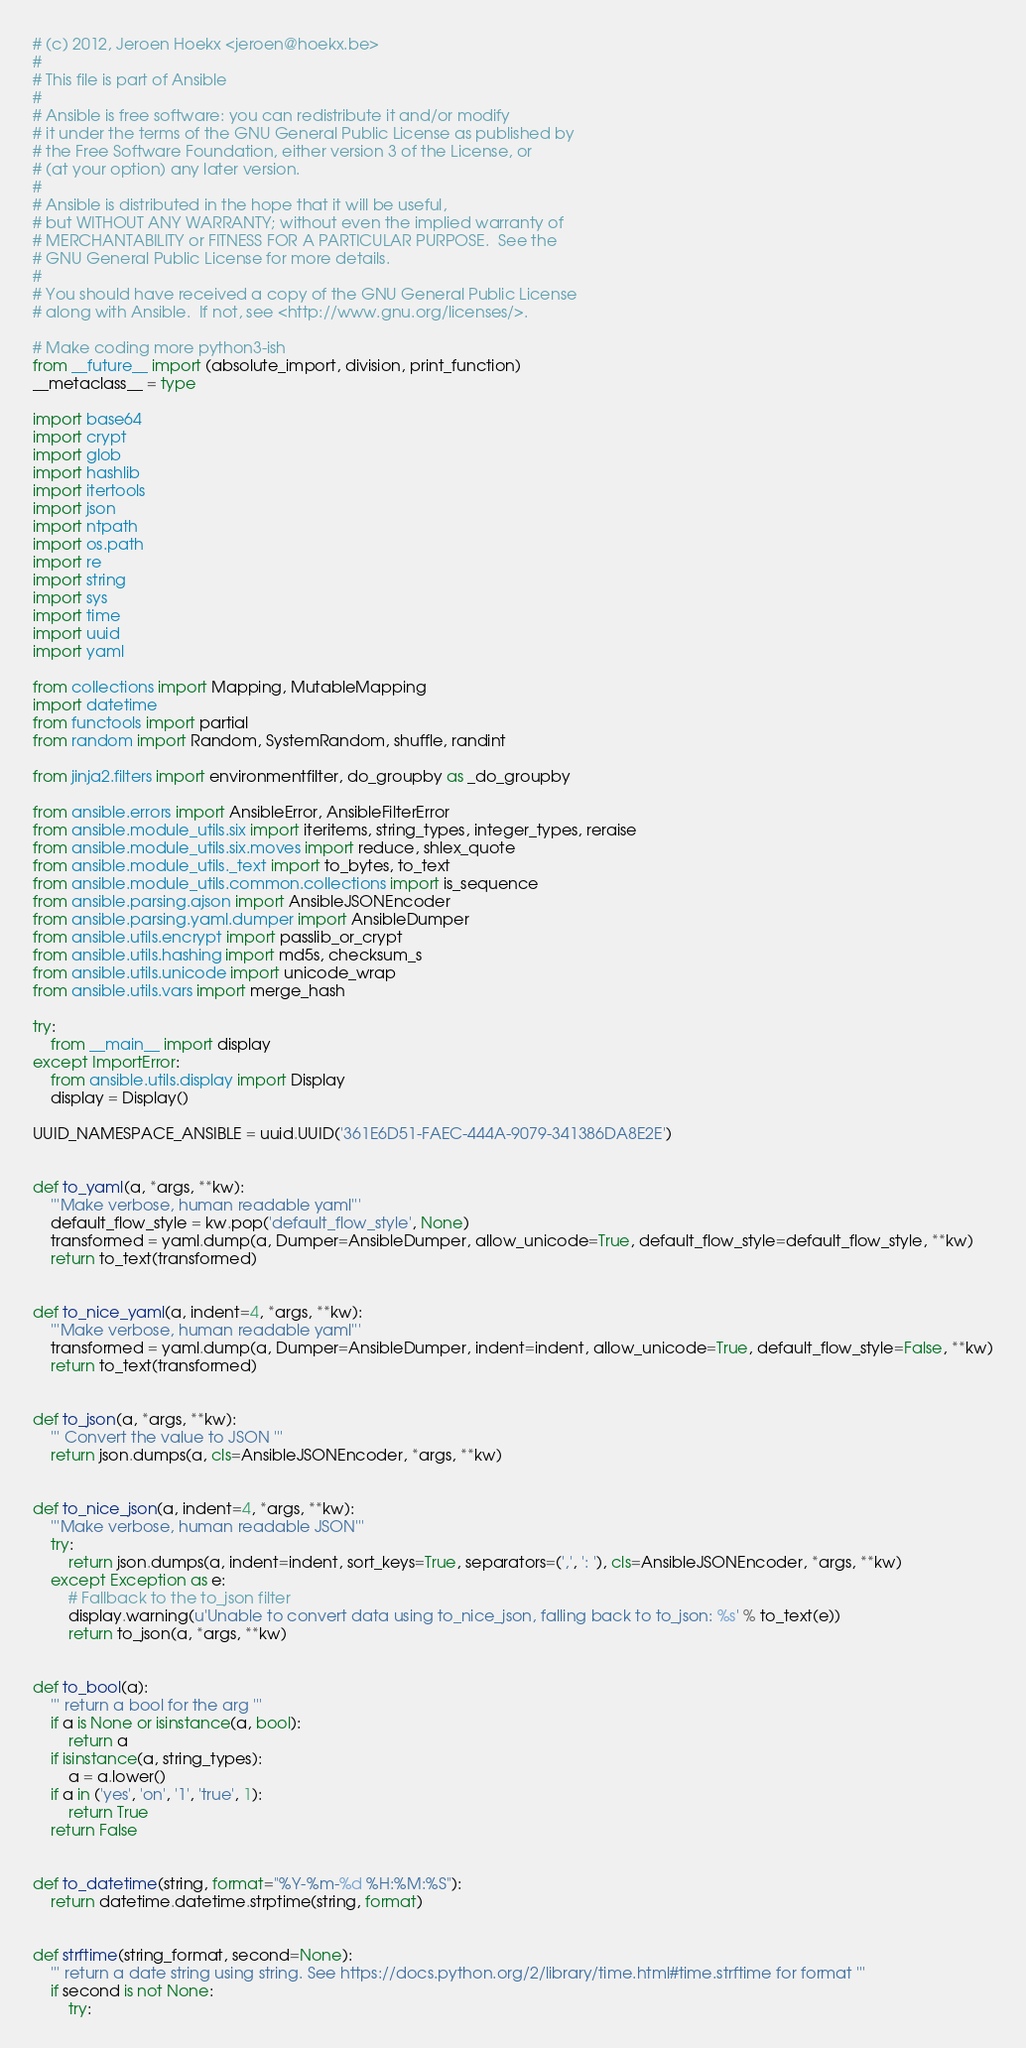<code> <loc_0><loc_0><loc_500><loc_500><_Python_># (c) 2012, Jeroen Hoekx <jeroen@hoekx.be>
#
# This file is part of Ansible
#
# Ansible is free software: you can redistribute it and/or modify
# it under the terms of the GNU General Public License as published by
# the Free Software Foundation, either version 3 of the License, or
# (at your option) any later version.
#
# Ansible is distributed in the hope that it will be useful,
# but WITHOUT ANY WARRANTY; without even the implied warranty of
# MERCHANTABILITY or FITNESS FOR A PARTICULAR PURPOSE.  See the
# GNU General Public License for more details.
#
# You should have received a copy of the GNU General Public License
# along with Ansible.  If not, see <http://www.gnu.org/licenses/>.

# Make coding more python3-ish
from __future__ import (absolute_import, division, print_function)
__metaclass__ = type

import base64
import crypt
import glob
import hashlib
import itertools
import json
import ntpath
import os.path
import re
import string
import sys
import time
import uuid
import yaml

from collections import Mapping, MutableMapping
import datetime
from functools import partial
from random import Random, SystemRandom, shuffle, randint

from jinja2.filters import environmentfilter, do_groupby as _do_groupby

from ansible.errors import AnsibleError, AnsibleFilterError
from ansible.module_utils.six import iteritems, string_types, integer_types, reraise
from ansible.module_utils.six.moves import reduce, shlex_quote
from ansible.module_utils._text import to_bytes, to_text
from ansible.module_utils.common.collections import is_sequence
from ansible.parsing.ajson import AnsibleJSONEncoder
from ansible.parsing.yaml.dumper import AnsibleDumper
from ansible.utils.encrypt import passlib_or_crypt
from ansible.utils.hashing import md5s, checksum_s
from ansible.utils.unicode import unicode_wrap
from ansible.utils.vars import merge_hash

try:
    from __main__ import display
except ImportError:
    from ansible.utils.display import Display
    display = Display()

UUID_NAMESPACE_ANSIBLE = uuid.UUID('361E6D51-FAEC-444A-9079-341386DA8E2E')


def to_yaml(a, *args, **kw):
    '''Make verbose, human readable yaml'''
    default_flow_style = kw.pop('default_flow_style', None)
    transformed = yaml.dump(a, Dumper=AnsibleDumper, allow_unicode=True, default_flow_style=default_flow_style, **kw)
    return to_text(transformed)


def to_nice_yaml(a, indent=4, *args, **kw):
    '''Make verbose, human readable yaml'''
    transformed = yaml.dump(a, Dumper=AnsibleDumper, indent=indent, allow_unicode=True, default_flow_style=False, **kw)
    return to_text(transformed)


def to_json(a, *args, **kw):
    ''' Convert the value to JSON '''
    return json.dumps(a, cls=AnsibleJSONEncoder, *args, **kw)


def to_nice_json(a, indent=4, *args, **kw):
    '''Make verbose, human readable JSON'''
    try:
        return json.dumps(a, indent=indent, sort_keys=True, separators=(',', ': '), cls=AnsibleJSONEncoder, *args, **kw)
    except Exception as e:
        # Fallback to the to_json filter
        display.warning(u'Unable to convert data using to_nice_json, falling back to to_json: %s' % to_text(e))
        return to_json(a, *args, **kw)


def to_bool(a):
    ''' return a bool for the arg '''
    if a is None or isinstance(a, bool):
        return a
    if isinstance(a, string_types):
        a = a.lower()
    if a in ('yes', 'on', '1', 'true', 1):
        return True
    return False


def to_datetime(string, format="%Y-%m-%d %H:%M:%S"):
    return datetime.datetime.strptime(string, format)


def strftime(string_format, second=None):
    ''' return a date string using string. See https://docs.python.org/2/library/time.html#time.strftime for format '''
    if second is not None:
        try:</code> 